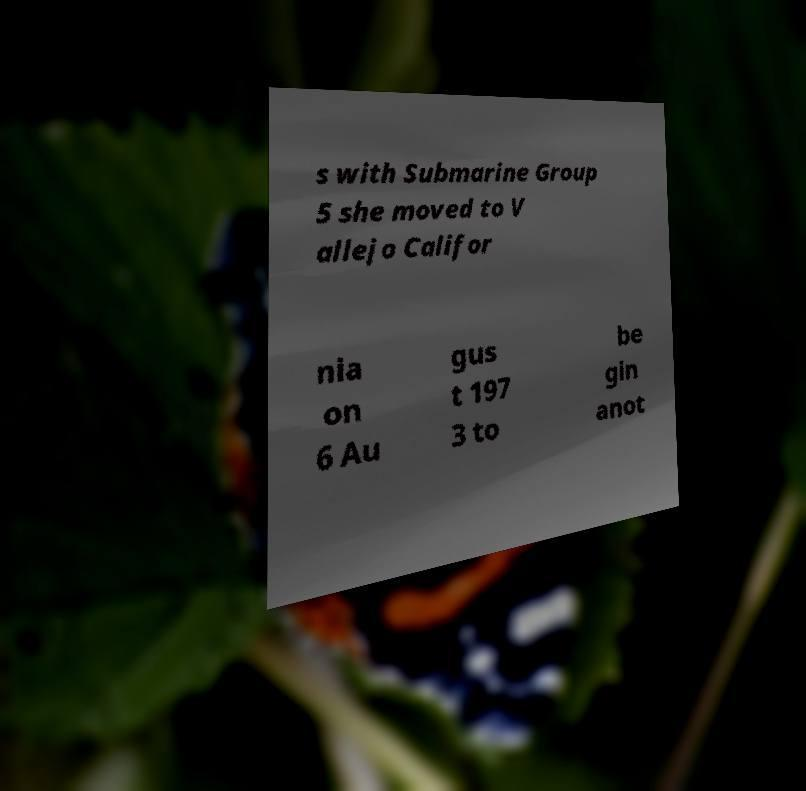Could you assist in decoding the text presented in this image and type it out clearly? s with Submarine Group 5 she moved to V allejo Califor nia on 6 Au gus t 197 3 to be gin anot 